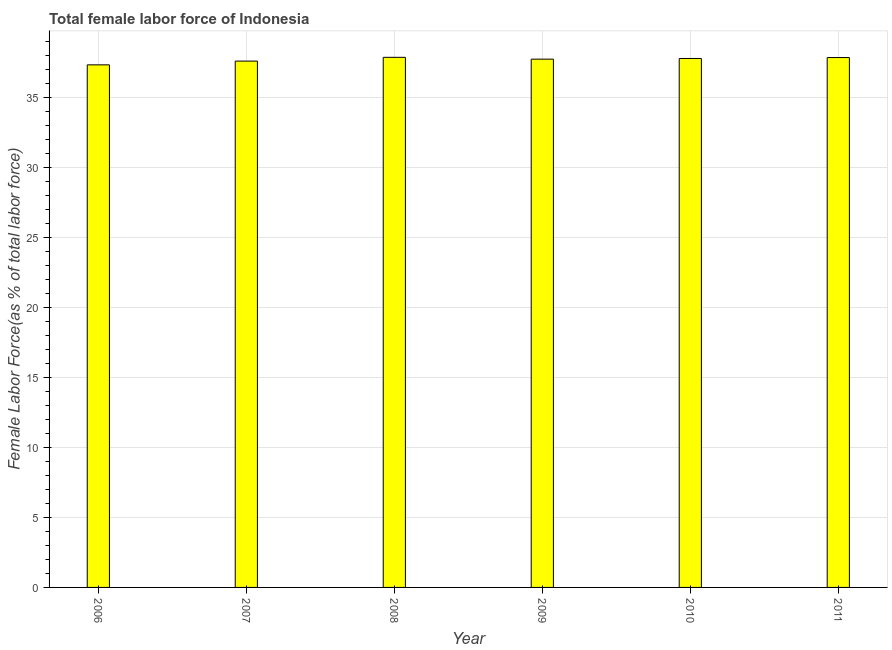Does the graph contain grids?
Ensure brevity in your answer.  Yes. What is the title of the graph?
Make the answer very short. Total female labor force of Indonesia. What is the label or title of the X-axis?
Your answer should be very brief. Year. What is the label or title of the Y-axis?
Keep it short and to the point. Female Labor Force(as % of total labor force). What is the total female labor force in 2010?
Give a very brief answer. 37.76. Across all years, what is the maximum total female labor force?
Provide a short and direct response. 37.85. Across all years, what is the minimum total female labor force?
Give a very brief answer. 37.31. What is the sum of the total female labor force?
Your answer should be compact. 226.05. What is the difference between the total female labor force in 2008 and 2009?
Keep it short and to the point. 0.13. What is the average total female labor force per year?
Make the answer very short. 37.67. What is the median total female labor force?
Offer a very short reply. 37.74. In how many years, is the total female labor force greater than 4 %?
Your answer should be compact. 6. What is the ratio of the total female labor force in 2009 to that in 2011?
Offer a terse response. 1. Is the total female labor force in 2007 less than that in 2008?
Give a very brief answer. Yes. What is the difference between the highest and the second highest total female labor force?
Your response must be concise. 0.02. Is the sum of the total female labor force in 2006 and 2010 greater than the maximum total female labor force across all years?
Give a very brief answer. Yes. What is the difference between the highest and the lowest total female labor force?
Offer a very short reply. 0.54. In how many years, is the total female labor force greater than the average total female labor force taken over all years?
Make the answer very short. 4. How many bars are there?
Offer a terse response. 6. Are all the bars in the graph horizontal?
Offer a terse response. No. What is the difference between two consecutive major ticks on the Y-axis?
Offer a terse response. 5. What is the Female Labor Force(as % of total labor force) of 2006?
Offer a very short reply. 37.31. What is the Female Labor Force(as % of total labor force) of 2007?
Keep it short and to the point. 37.58. What is the Female Labor Force(as % of total labor force) in 2008?
Provide a succinct answer. 37.85. What is the Female Labor Force(as % of total labor force) in 2009?
Your answer should be very brief. 37.72. What is the Female Labor Force(as % of total labor force) in 2010?
Offer a terse response. 37.76. What is the Female Labor Force(as % of total labor force) in 2011?
Keep it short and to the point. 37.83. What is the difference between the Female Labor Force(as % of total labor force) in 2006 and 2007?
Give a very brief answer. -0.27. What is the difference between the Female Labor Force(as % of total labor force) in 2006 and 2008?
Your answer should be compact. -0.54. What is the difference between the Female Labor Force(as % of total labor force) in 2006 and 2009?
Offer a terse response. -0.41. What is the difference between the Female Labor Force(as % of total labor force) in 2006 and 2010?
Your response must be concise. -0.45. What is the difference between the Female Labor Force(as % of total labor force) in 2006 and 2011?
Give a very brief answer. -0.52. What is the difference between the Female Labor Force(as % of total labor force) in 2007 and 2008?
Offer a very short reply. -0.27. What is the difference between the Female Labor Force(as % of total labor force) in 2007 and 2009?
Give a very brief answer. -0.14. What is the difference between the Female Labor Force(as % of total labor force) in 2007 and 2010?
Offer a very short reply. -0.19. What is the difference between the Female Labor Force(as % of total labor force) in 2007 and 2011?
Provide a short and direct response. -0.25. What is the difference between the Female Labor Force(as % of total labor force) in 2008 and 2009?
Your answer should be compact. 0.13. What is the difference between the Female Labor Force(as % of total labor force) in 2008 and 2010?
Keep it short and to the point. 0.08. What is the difference between the Female Labor Force(as % of total labor force) in 2008 and 2011?
Your response must be concise. 0.02. What is the difference between the Female Labor Force(as % of total labor force) in 2009 and 2010?
Your response must be concise. -0.05. What is the difference between the Female Labor Force(as % of total labor force) in 2009 and 2011?
Give a very brief answer. -0.11. What is the difference between the Female Labor Force(as % of total labor force) in 2010 and 2011?
Ensure brevity in your answer.  -0.07. What is the ratio of the Female Labor Force(as % of total labor force) in 2006 to that in 2007?
Make the answer very short. 0.99. What is the ratio of the Female Labor Force(as % of total labor force) in 2006 to that in 2008?
Your answer should be compact. 0.99. What is the ratio of the Female Labor Force(as % of total labor force) in 2006 to that in 2009?
Keep it short and to the point. 0.99. What is the ratio of the Female Labor Force(as % of total labor force) in 2006 to that in 2010?
Give a very brief answer. 0.99. What is the ratio of the Female Labor Force(as % of total labor force) in 2007 to that in 2008?
Ensure brevity in your answer.  0.99. What is the ratio of the Female Labor Force(as % of total labor force) in 2007 to that in 2010?
Offer a terse response. 0.99. What is the ratio of the Female Labor Force(as % of total labor force) in 2008 to that in 2010?
Make the answer very short. 1. What is the ratio of the Female Labor Force(as % of total labor force) in 2008 to that in 2011?
Provide a succinct answer. 1. What is the ratio of the Female Labor Force(as % of total labor force) in 2009 to that in 2010?
Provide a succinct answer. 1. What is the ratio of the Female Labor Force(as % of total labor force) in 2010 to that in 2011?
Give a very brief answer. 1. 